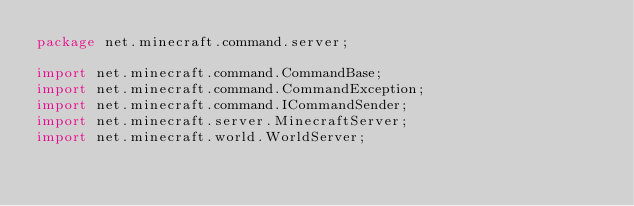Convert code to text. <code><loc_0><loc_0><loc_500><loc_500><_Java_>package net.minecraft.command.server;

import net.minecraft.command.CommandBase;
import net.minecraft.command.CommandException;
import net.minecraft.command.ICommandSender;
import net.minecraft.server.MinecraftServer;
import net.minecraft.world.WorldServer;
</code> 